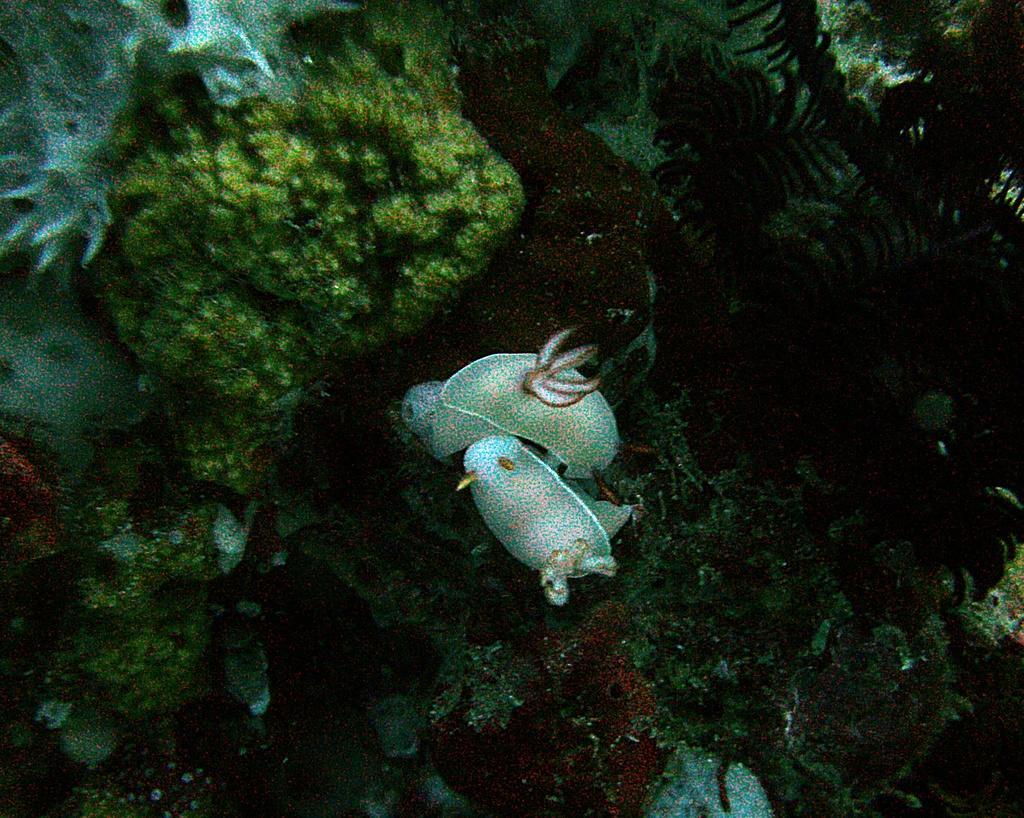Please provide a concise description of this image. Here in this picture we can see underwater plants, rock stones and some fishes present. 